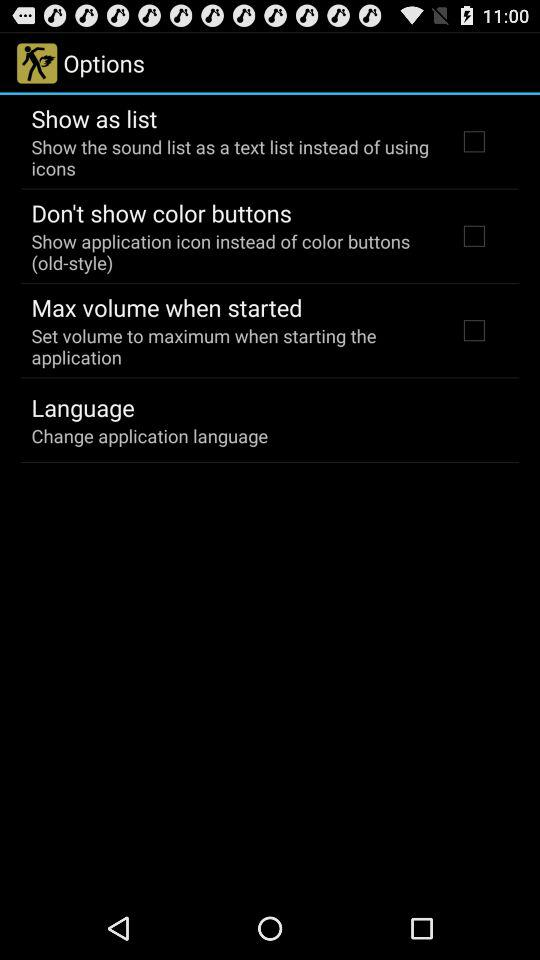What is the status of the "Show as list"? The status is "off". 